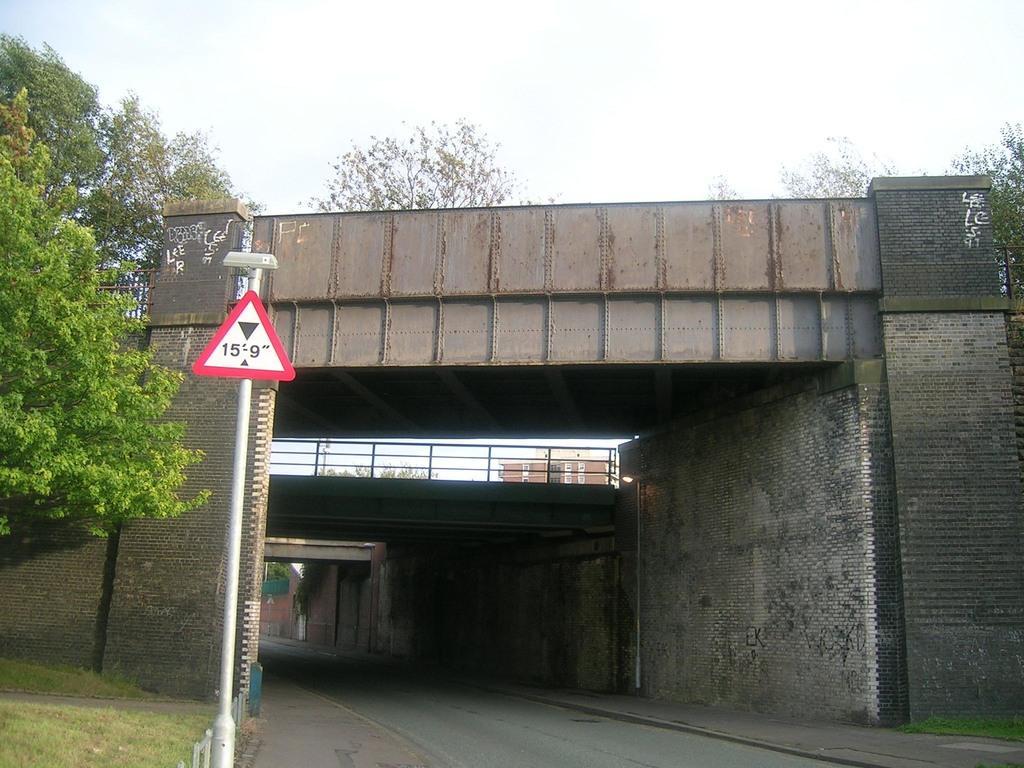Can you describe this image briefly? In this image, we can see bridges, railings, walls, pole with sign board, trees, plants, walkways and road. In the background, we can see the sky and building. 